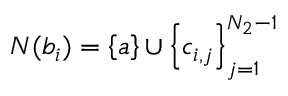<formula> <loc_0><loc_0><loc_500><loc_500>N ( b _ { i } ) = \left \{ a \right \} \cup \left \{ c _ { i , j } \right \} _ { j = 1 } ^ { N _ { 2 } - 1 }</formula> 